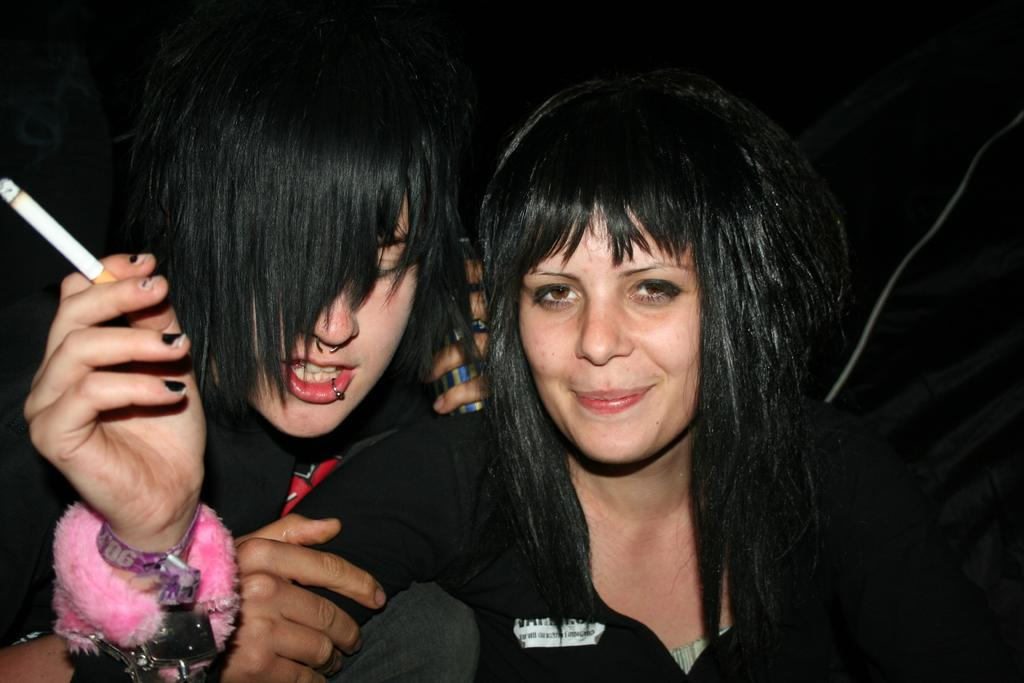How many ladies are present in the image? There are two ladies in the image. What is the lady on the right wearing on her wrists? The lady on the right is wearing wrist bands. What is the lady on the right holding? The lady on the right is holding a cigarette. What is the other lady holding in the back? The other lady is holding something in the back, but the specific object is not clear from the image. What is the color of the background in the image? The background of the image is dark. What type of beast can be seen in the image? There is no beast present in the image; it features two ladies. What nerve is responsible for the lady on the right's ability to hold a cigarette? The image does not provide information about the lady's nervous system or the specific nerve responsible for holding a cigarette. --- Facts: 1. There is a car in the image. 2. The car is red. 3. The car has four wheels. 4. There is a person sitting in the car. 5. The person is wearing a hat. Absurd Topics: parrot, ocean, mountain Conversation: What is the main subject of the image? The main subject of the image is a car. What color is the car? The car is red. How many wheels does the car have? The car has four wheels. Is there anyone inside the car? Yes, there is a person sitting in the car. What is the person wearing? The person is wearing a hat. Reasoning: Let's think step by step in order to produce the conversation. We start by identifying the main subject of the image, which is the car. Then, we describe specific details about the car, such as its color and the number of wheels. We also mention the presence of a person inside the car and their attire, which is a hat. Absurd Question/Answer: Can you see any parrots flying over the ocean in the image? There is no ocean or parrots present in the image; it features a red car with a person wearing a hat. Is there a mountain visible in the background of the image? There is no mountain visible in the image; it features a red car with a person wearing a hat. 